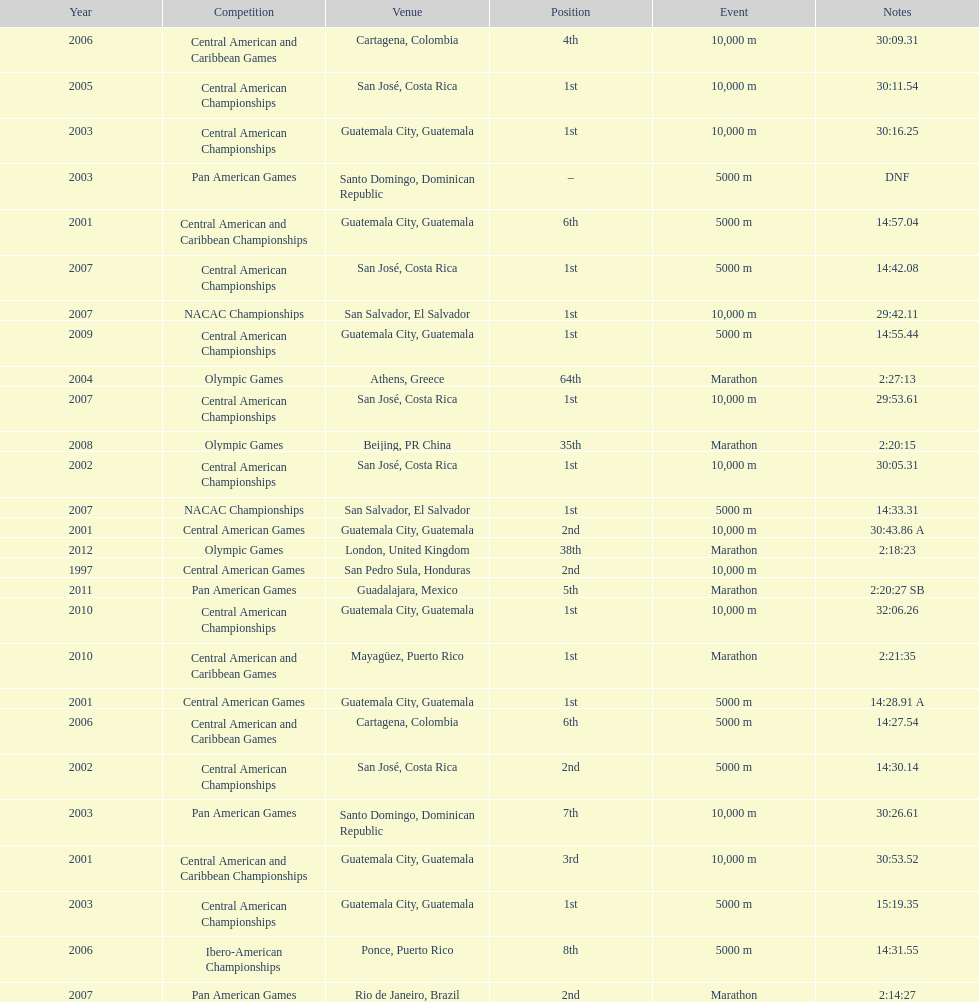In which most recent contest was a rank of "2nd" attained? Pan American Games. 